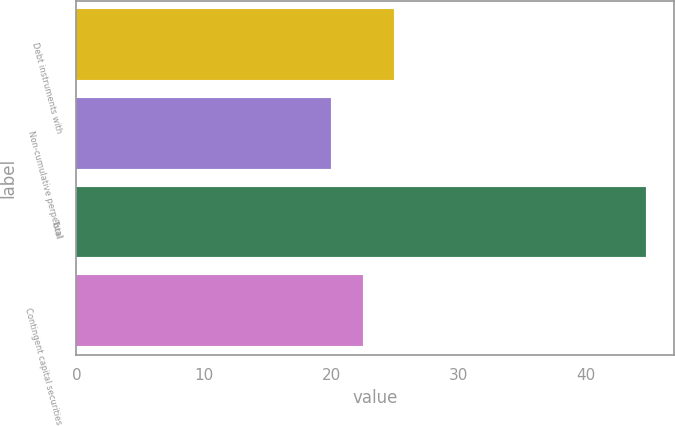Convert chart. <chart><loc_0><loc_0><loc_500><loc_500><bar_chart><fcel>Debt instruments with<fcel>Non-cumulative perpetual<fcel>Total<fcel>Contingent capital securities<nl><fcel>24.94<fcel>20<fcel>44.7<fcel>22.47<nl></chart> 